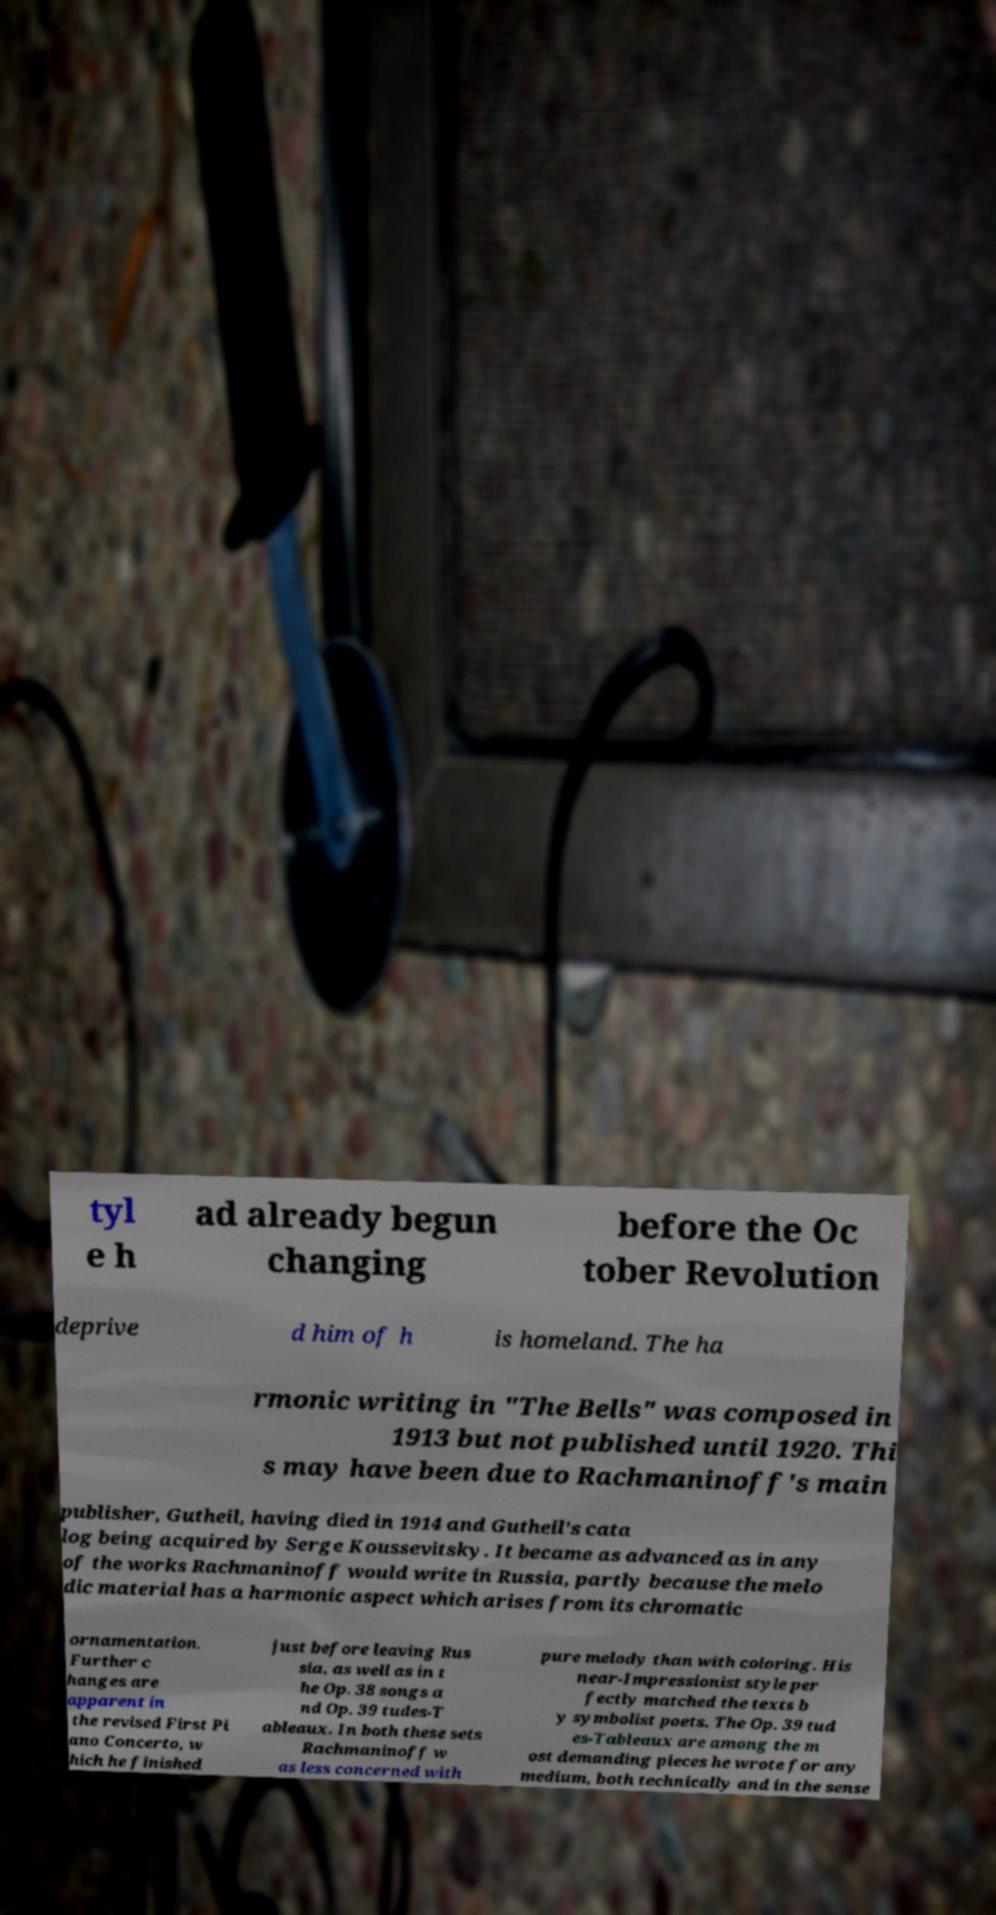For documentation purposes, I need the text within this image transcribed. Could you provide that? tyl e h ad already begun changing before the Oc tober Revolution deprive d him of h is homeland. The ha rmonic writing in "The Bells" was composed in 1913 but not published until 1920. Thi s may have been due to Rachmaninoff's main publisher, Gutheil, having died in 1914 and Gutheil's cata log being acquired by Serge Koussevitsky. It became as advanced as in any of the works Rachmaninoff would write in Russia, partly because the melo dic material has a harmonic aspect which arises from its chromatic ornamentation. Further c hanges are apparent in the revised First Pi ano Concerto, w hich he finished just before leaving Rus sia, as well as in t he Op. 38 songs a nd Op. 39 tudes-T ableaux. In both these sets Rachmaninoff w as less concerned with pure melody than with coloring. His near-Impressionist style per fectly matched the texts b y symbolist poets. The Op. 39 tud es-Tableaux are among the m ost demanding pieces he wrote for any medium, both technically and in the sense 